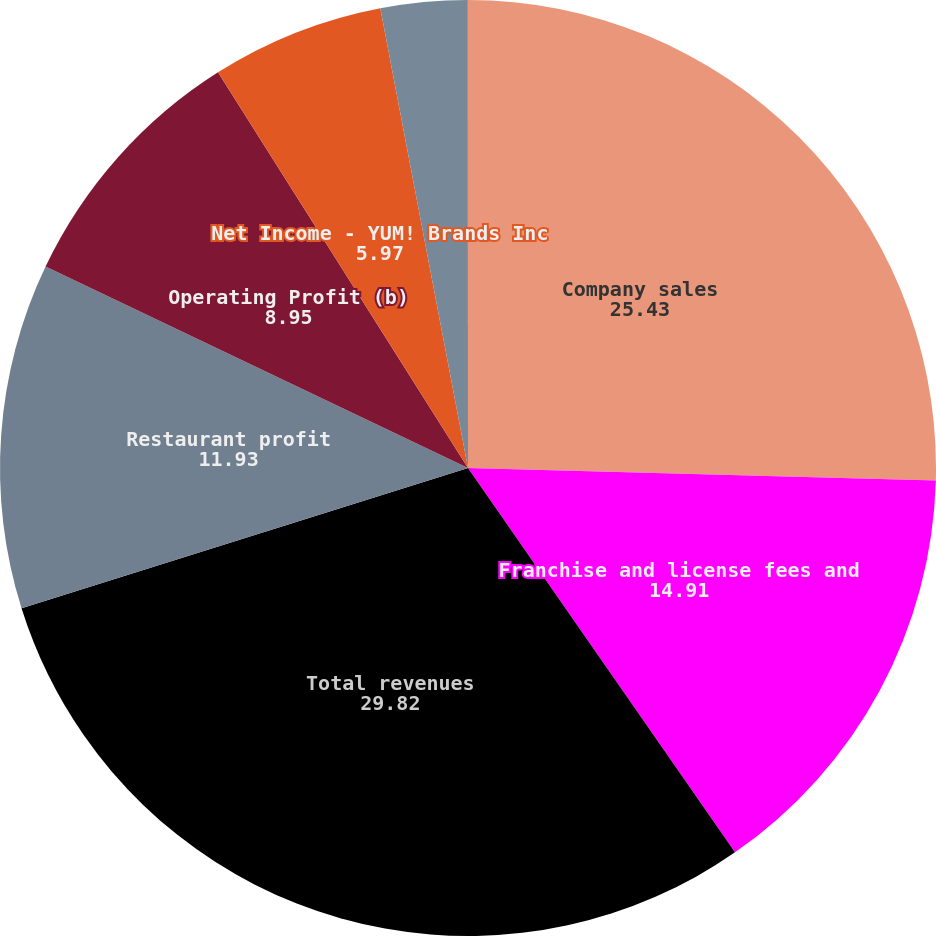<chart> <loc_0><loc_0><loc_500><loc_500><pie_chart><fcel>Company sales<fcel>Franchise and license fees and<fcel>Total revenues<fcel>Restaurant profit<fcel>Operating Profit (b)<fcel>Net Income - YUM! Brands Inc<fcel>Basic earnings per common<fcel>Diluted earnings per common<nl><fcel>25.43%<fcel>14.91%<fcel>29.82%<fcel>11.93%<fcel>8.95%<fcel>5.97%<fcel>2.99%<fcel>0.01%<nl></chart> 